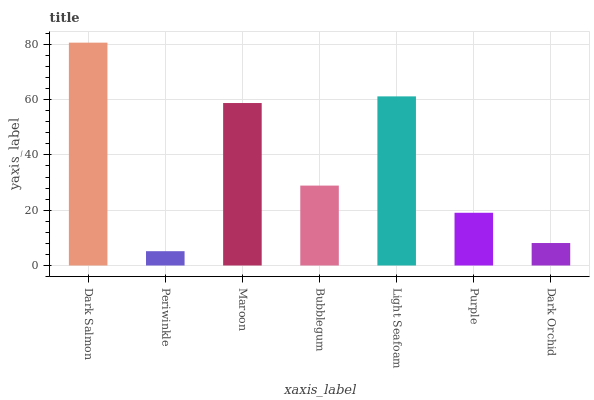Is Maroon the minimum?
Answer yes or no. No. Is Maroon the maximum?
Answer yes or no. No. Is Maroon greater than Periwinkle?
Answer yes or no. Yes. Is Periwinkle less than Maroon?
Answer yes or no. Yes. Is Periwinkle greater than Maroon?
Answer yes or no. No. Is Maroon less than Periwinkle?
Answer yes or no. No. Is Bubblegum the high median?
Answer yes or no. Yes. Is Bubblegum the low median?
Answer yes or no. Yes. Is Maroon the high median?
Answer yes or no. No. Is Dark Salmon the low median?
Answer yes or no. No. 